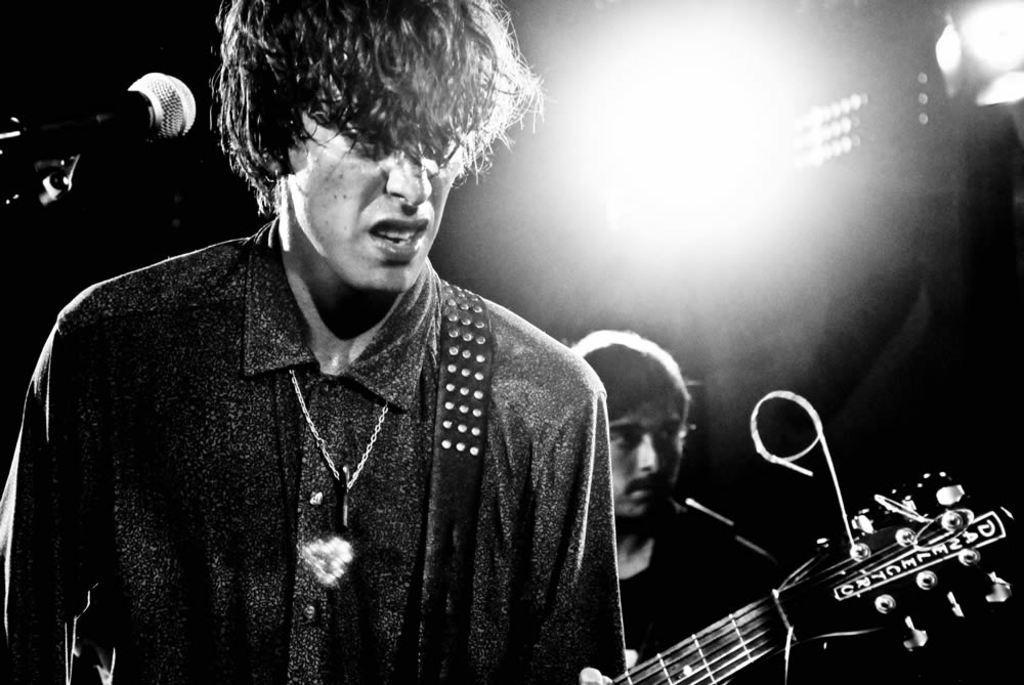In one or two sentences, can you explain what this image depicts? In the image we can see two person. This person is holding a guitar in his hand. This is a microphone. 